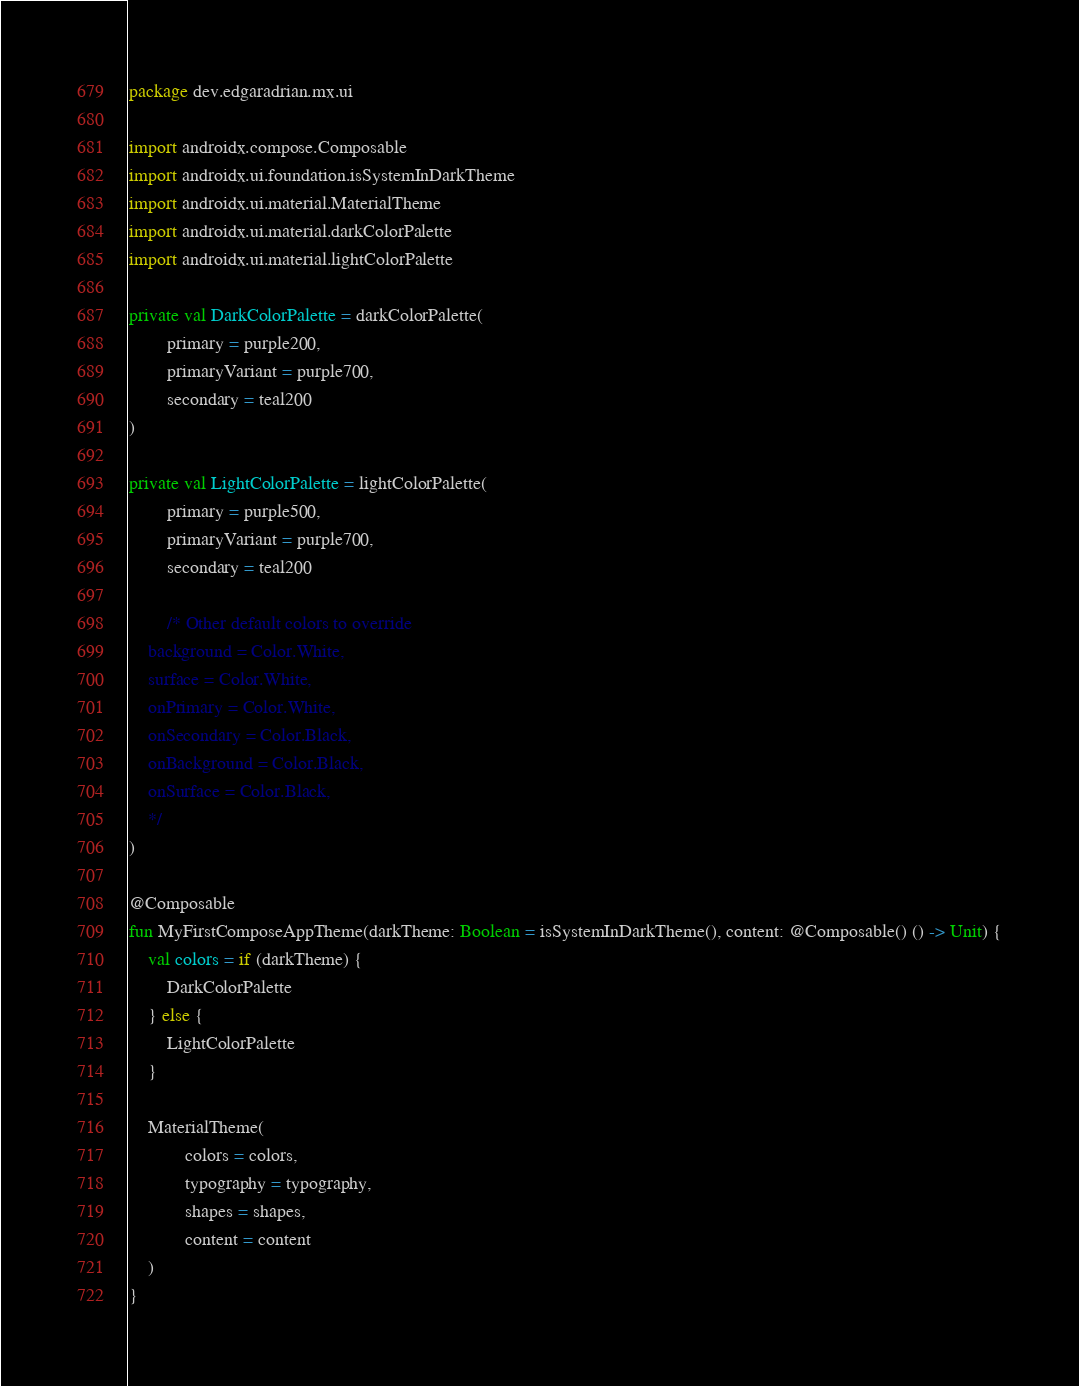Convert code to text. <code><loc_0><loc_0><loc_500><loc_500><_Kotlin_>package dev.edgaradrian.mx.ui

import androidx.compose.Composable
import androidx.ui.foundation.isSystemInDarkTheme
import androidx.ui.material.MaterialTheme
import androidx.ui.material.darkColorPalette
import androidx.ui.material.lightColorPalette

private val DarkColorPalette = darkColorPalette(
        primary = purple200,
        primaryVariant = purple700,
        secondary = teal200
)

private val LightColorPalette = lightColorPalette(
        primary = purple500,
        primaryVariant = purple700,
        secondary = teal200

        /* Other default colors to override
    background = Color.White,
    surface = Color.White,
    onPrimary = Color.White,
    onSecondary = Color.Black,
    onBackground = Color.Black,
    onSurface = Color.Black,
    */
)

@Composable
fun MyFirstComposeAppTheme(darkTheme: Boolean = isSystemInDarkTheme(), content: @Composable() () -> Unit) {
    val colors = if (darkTheme) {
        DarkColorPalette
    } else {
        LightColorPalette
    }

    MaterialTheme(
            colors = colors,
            typography = typography,
            shapes = shapes,
            content = content
    )
}</code> 